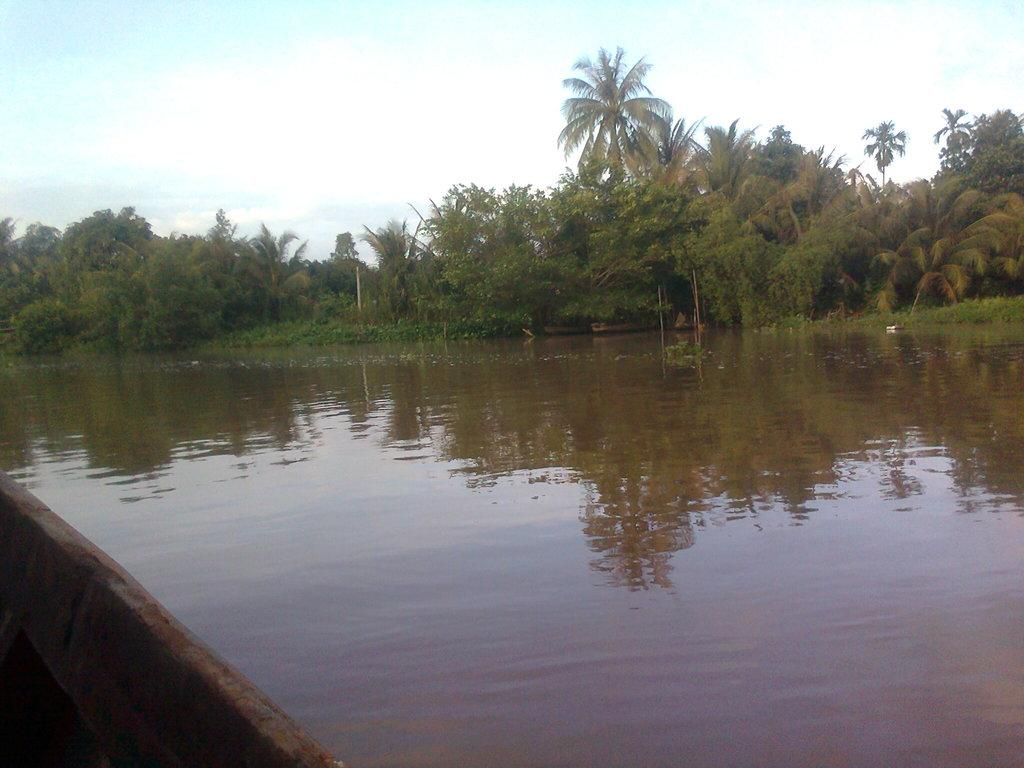What is the main subject in the center of the image? There is water at the center of the image. What type of natural environment can be seen in the background? There are trees in the background of the image. What is visible at the top of the image? The sky is visible at the top of the image. Where is the father's boot located in the image? There is no father or boot present in the image. What is the head doing in the image? There is no head present in the image. 